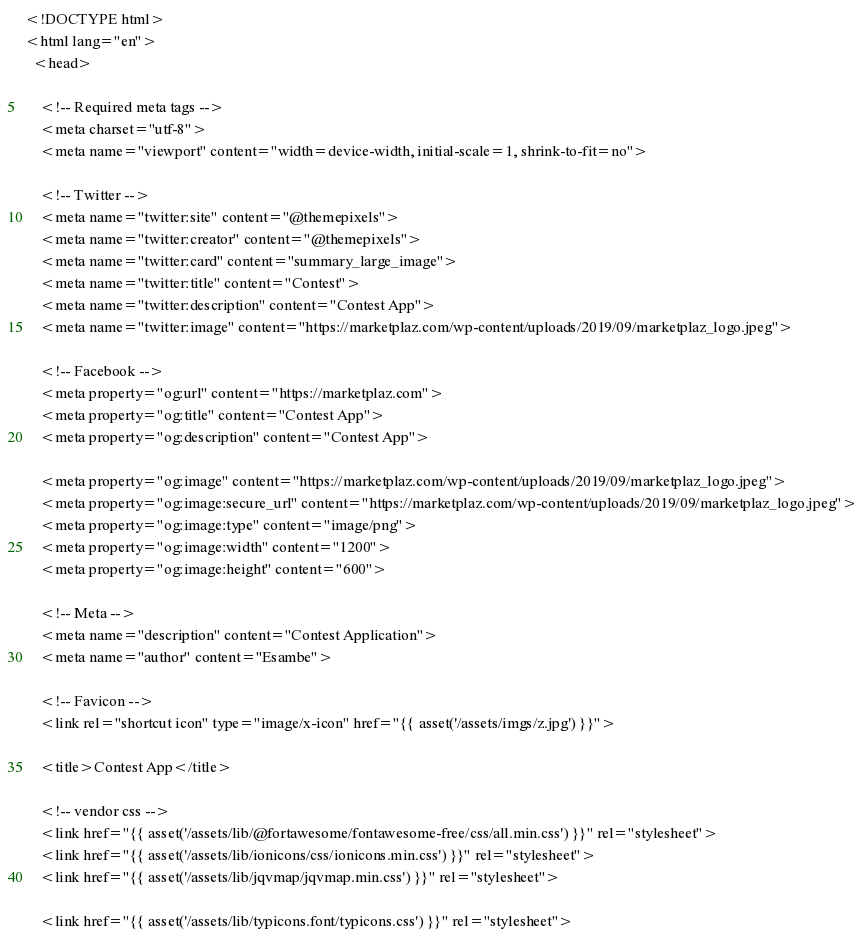Convert code to text. <code><loc_0><loc_0><loc_500><loc_500><_PHP_><!DOCTYPE html>
<html lang="en">
  <head>

    <!-- Required meta tags -->
    <meta charset="utf-8">
    <meta name="viewport" content="width=device-width, initial-scale=1, shrink-to-fit=no">

    <!-- Twitter -->
    <meta name="twitter:site" content="@themepixels">
    <meta name="twitter:creator" content="@themepixels">
    <meta name="twitter:card" content="summary_large_image">
    <meta name="twitter:title" content="Contest">
    <meta name="twitter:description" content="Contest App">
    <meta name="twitter:image" content="https://marketplaz.com/wp-content/uploads/2019/09/marketplaz_logo.jpeg">

    <!-- Facebook -->
    <meta property="og:url" content="https://marketplaz.com">
    <meta property="og:title" content="Contest App">
    <meta property="og:description" content="Contest App">

    <meta property="og:image" content="https://marketplaz.com/wp-content/uploads/2019/09/marketplaz_logo.jpeg">
    <meta property="og:image:secure_url" content="https://marketplaz.com/wp-content/uploads/2019/09/marketplaz_logo.jpeg">
    <meta property="og:image:type" content="image/png">
    <meta property="og:image:width" content="1200">
    <meta property="og:image:height" content="600">

    <!-- Meta -->
    <meta name="description" content="Contest Application">
    <meta name="author" content="Esambe">

    <!-- Favicon -->
    <link rel="shortcut icon" type="image/x-icon" href="{{ asset('/assets/imgs/z.jpg') }}">

    <title>Contest App</title>

    <!-- vendor css -->
    <link href="{{ asset('/assets/lib/@fortawesome/fontawesome-free/css/all.min.css') }}" rel="stylesheet">
    <link href="{{ asset('/assets/lib/ionicons/css/ionicons.min.css') }}" rel="stylesheet">
    <link href="{{ asset('/assets/lib/jqvmap/jqvmap.min.css') }}" rel="stylesheet">

    <link href="{{ asset('/assets/lib/typicons.font/typicons.css') }}" rel="stylesheet"></code> 